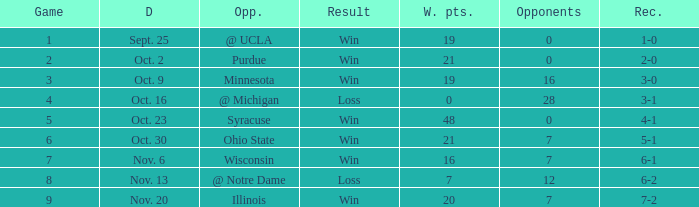What is the lowest points scored by the Wildcats when the record was 5-1? 21.0. 